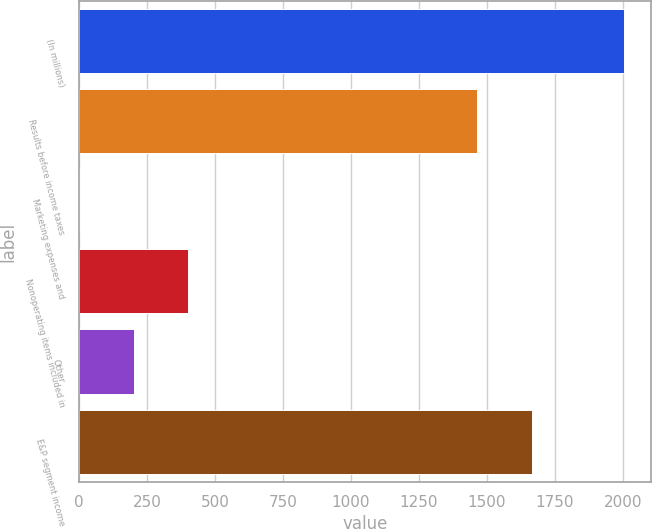<chart> <loc_0><loc_0><loc_500><loc_500><bar_chart><fcel>(In millions)<fcel>Results before income taxes<fcel>Marketing expenses and<fcel>Nonoperating items included in<fcel>Other<fcel>E&P segment income<nl><fcel>2003<fcel>1465<fcel>3<fcel>403<fcel>203<fcel>1665<nl></chart> 